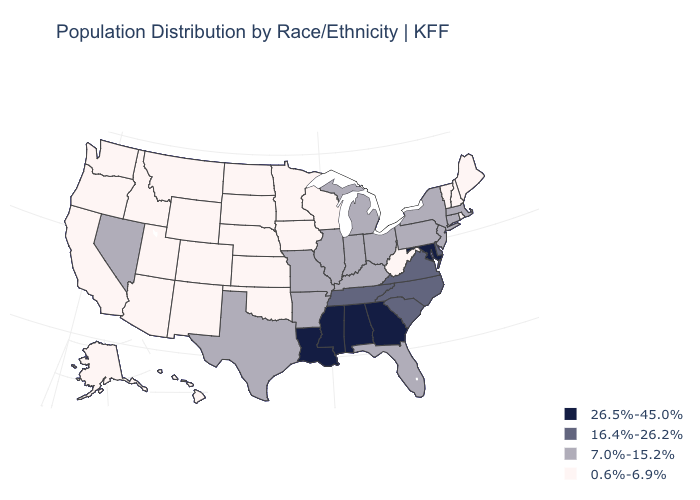What is the highest value in the USA?
Be succinct. 26.5%-45.0%. What is the value of Massachusetts?
Answer briefly. 7.0%-15.2%. Does Indiana have the lowest value in the USA?
Concise answer only. No. Name the states that have a value in the range 16.4%-26.2%?
Give a very brief answer. Delaware, North Carolina, South Carolina, Tennessee, Virginia. Among the states that border Michigan , which have the highest value?
Be succinct. Indiana, Ohio. Name the states that have a value in the range 0.6%-6.9%?
Give a very brief answer. Alaska, Arizona, California, Colorado, Hawaii, Idaho, Iowa, Kansas, Maine, Minnesota, Montana, Nebraska, New Hampshire, New Mexico, North Dakota, Oklahoma, Oregon, Rhode Island, South Dakota, Utah, Vermont, Washington, West Virginia, Wisconsin, Wyoming. Name the states that have a value in the range 7.0%-15.2%?
Answer briefly. Arkansas, Connecticut, Florida, Illinois, Indiana, Kentucky, Massachusetts, Michigan, Missouri, Nevada, New Jersey, New York, Ohio, Pennsylvania, Texas. Does New Hampshire have a higher value than Kentucky?
Be succinct. No. What is the highest value in states that border New Jersey?
Give a very brief answer. 16.4%-26.2%. What is the lowest value in the USA?
Write a very short answer. 0.6%-6.9%. Does Iowa have a lower value than Alabama?
Keep it brief. Yes. Name the states that have a value in the range 26.5%-45.0%?
Answer briefly. Alabama, Georgia, Louisiana, Maryland, Mississippi. How many symbols are there in the legend?
Keep it brief. 4. What is the value of Indiana?
Give a very brief answer. 7.0%-15.2%. Which states have the lowest value in the West?
Answer briefly. Alaska, Arizona, California, Colorado, Hawaii, Idaho, Montana, New Mexico, Oregon, Utah, Washington, Wyoming. 